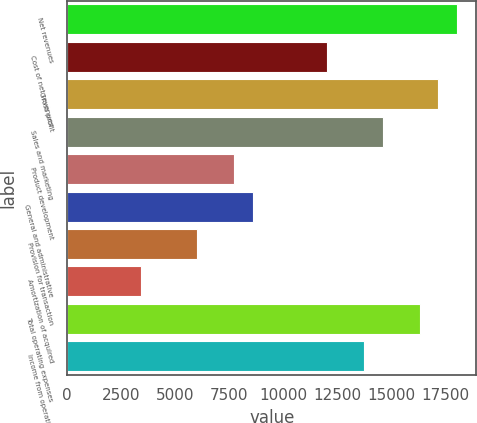Convert chart. <chart><loc_0><loc_0><loc_500><loc_500><bar_chart><fcel>Net revenues<fcel>Cost of net revenues<fcel>Gross profit<fcel>Sales and marketing<fcel>Product development<fcel>General and administrative<fcel>Provision for transaction<fcel>Amortization of acquired<fcel>Total operating expenses<fcel>Income from operations<nl><fcel>18043<fcel>12028.7<fcel>17183.8<fcel>14606.2<fcel>7732.8<fcel>8591.98<fcel>6014.44<fcel>3436.9<fcel>16324.6<fcel>13747.1<nl></chart> 